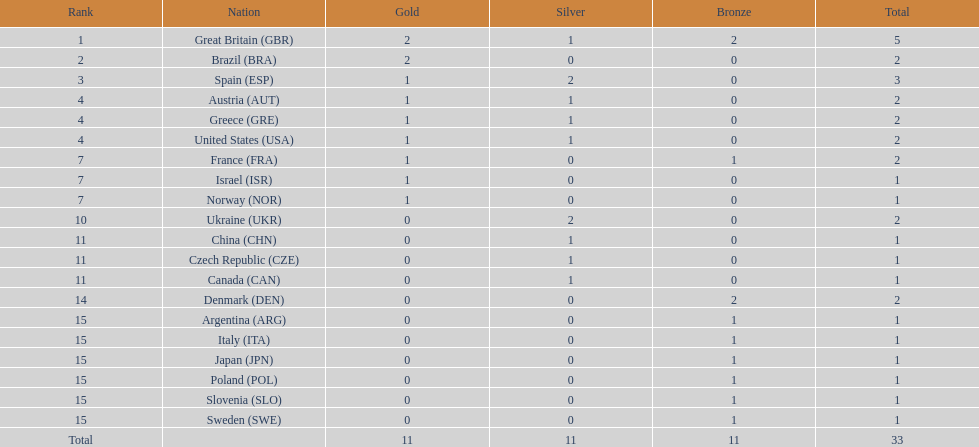What's the count of silver medals obtained by ukraine? 2. 